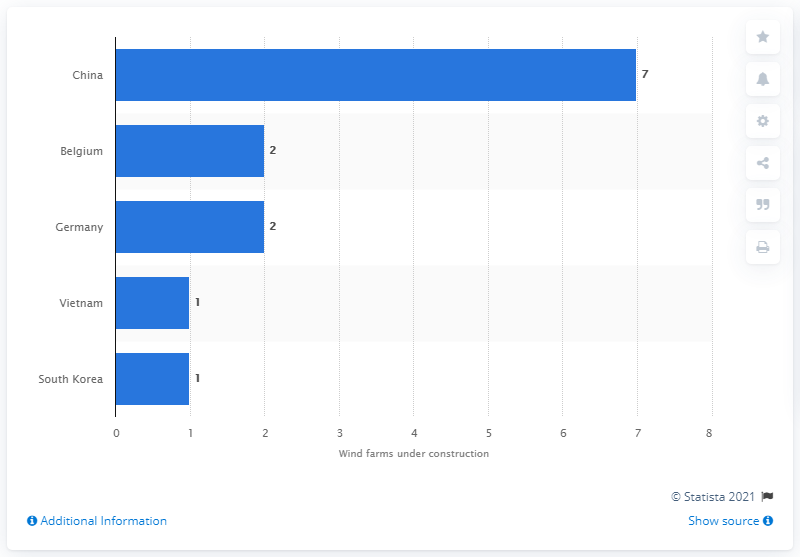Point out several critical features in this image. According to information available as of October 2019, Germany was the country that had two wind farm projects under construction. 